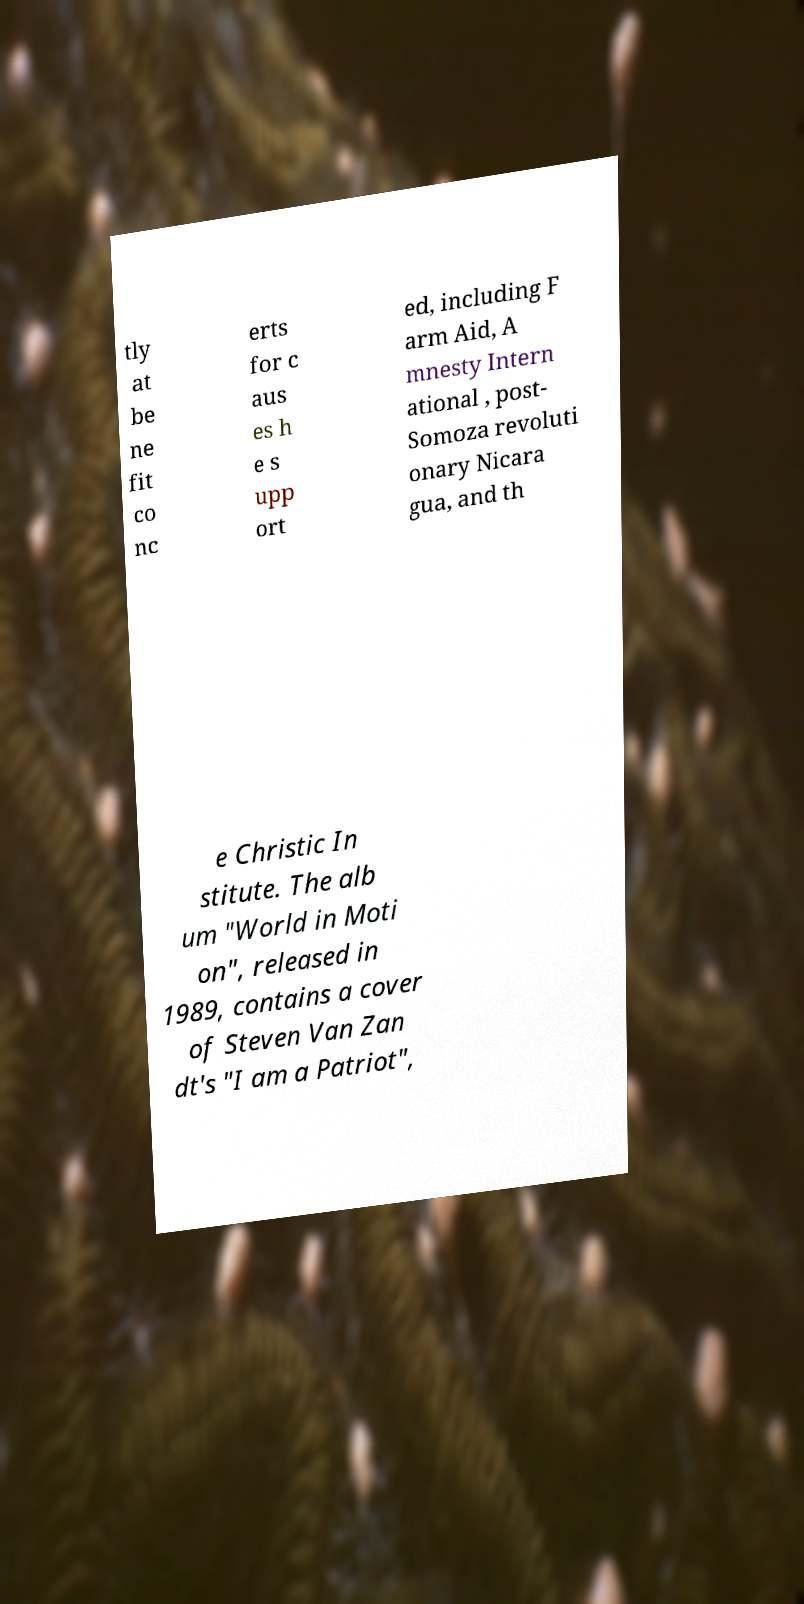Can you read and provide the text displayed in the image?This photo seems to have some interesting text. Can you extract and type it out for me? tly at be ne fit co nc erts for c aus es h e s upp ort ed, including F arm Aid, A mnesty Intern ational , post- Somoza revoluti onary Nicara gua, and th e Christic In stitute. The alb um "World in Moti on", released in 1989, contains a cover of Steven Van Zan dt's "I am a Patriot", 